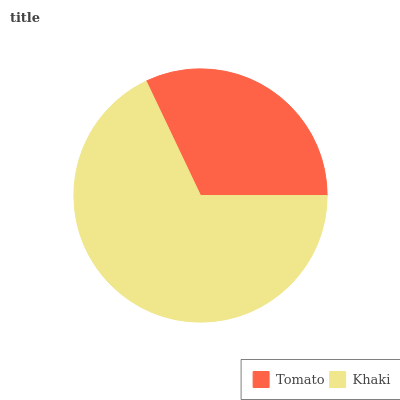Is Tomato the minimum?
Answer yes or no. Yes. Is Khaki the maximum?
Answer yes or no. Yes. Is Khaki the minimum?
Answer yes or no. No. Is Khaki greater than Tomato?
Answer yes or no. Yes. Is Tomato less than Khaki?
Answer yes or no. Yes. Is Tomato greater than Khaki?
Answer yes or no. No. Is Khaki less than Tomato?
Answer yes or no. No. Is Khaki the high median?
Answer yes or no. Yes. Is Tomato the low median?
Answer yes or no. Yes. Is Tomato the high median?
Answer yes or no. No. Is Khaki the low median?
Answer yes or no. No. 